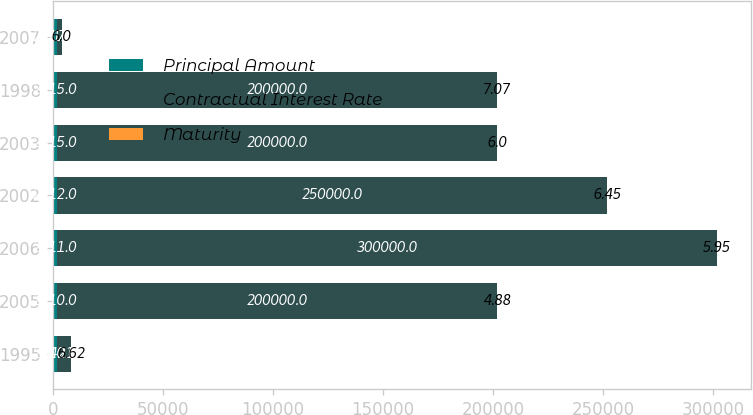Convert chart to OTSL. <chart><loc_0><loc_0><loc_500><loc_500><stacked_bar_chart><ecel><fcel>1995<fcel>2005<fcel>2006<fcel>2002<fcel>2003<fcel>1998<fcel>2007<nl><fcel>Principal Amount<fcel>2010<fcel>2010<fcel>2011<fcel>2012<fcel>2015<fcel>2015<fcel>2017<nl><fcel>Contractual Interest Rate<fcel>6421<fcel>200000<fcel>300000<fcel>250000<fcel>200000<fcel>200000<fcel>2011.5<nl><fcel>Maturity<fcel>6.62<fcel>4.88<fcel>5.95<fcel>6.45<fcel>6<fcel>7.07<fcel>6<nl></chart> 